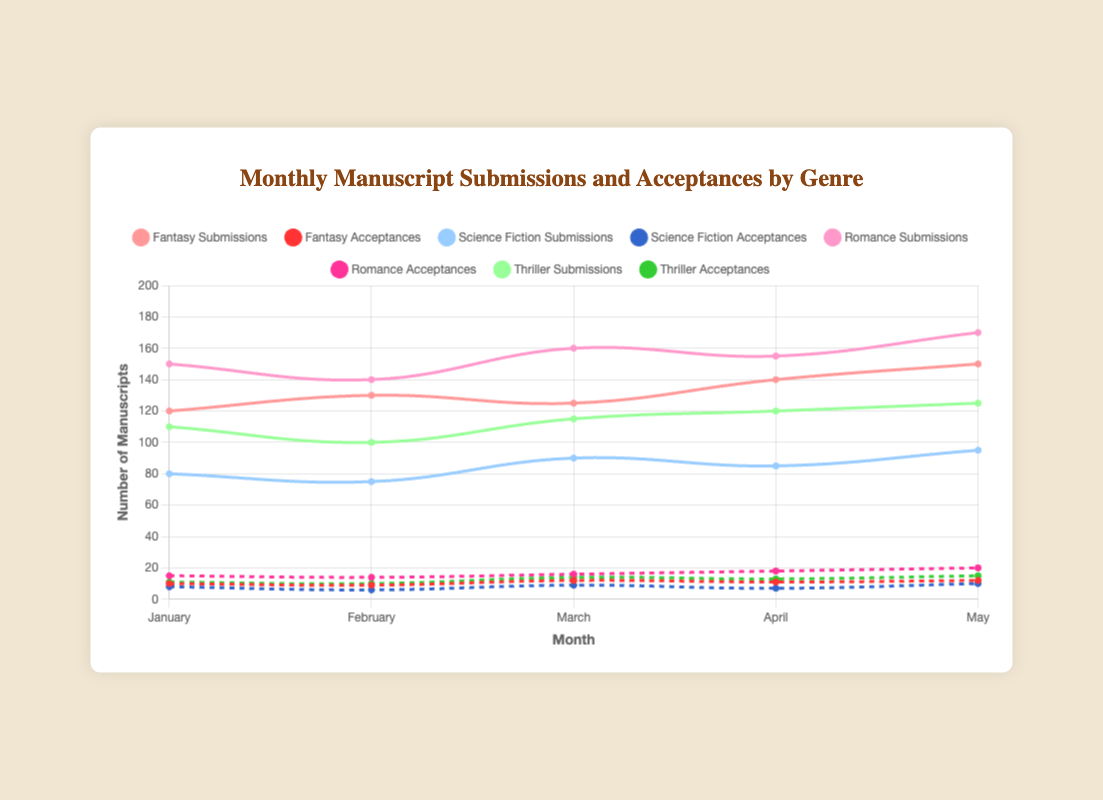What's the total number of Fantasy submissions over the five months? Sum the Fantasy submissions for each month: 120 + 130 + 125 + 140 + 150 = 665
Answer: 665 Which genre had the highest number of submissions in May? Compare the submission numbers in May across all genres: Fantasy (150), Science Fiction (95), Romance (170), Thriller (125). The highest is 170 for Romance.
Answer: Romance What is the difference between the number of Fantasy acceptances and Science Fiction acceptances in March? Find the number of acceptances for Fantasy (12) and Science Fiction (9) in March and calculate the difference: 12 - 9 = 3
Answer: 3 Which genre had the most consistent number of submissions from January to May? Visually compare the submission lines across the months for each genre. Look for the flattest line: Fantasy fluctuates (120 to 150), Science Fiction is relatively consistent (range 75 to 95), Romance has notable increases, Thriller is steady but slightly variable.
Answer: Science Fiction What's the average number of submissions for Romance from January to May? Sum the Romance submissions for each month and divide by 5: (150 + 140 + 160 + 155 + 170) / 5 = 775 / 5 = 155
Answer: 155 Which month saw the highest number of total manuscript submissions across all genres? Add the submissions for each month across all genres and compare: January (120+80+150+110 = 460), February (130+75+140+100 = 445), March (125+90+160+115 = 490), April (140+85+155+120 = 500), May (150+95+170+125 = 540). May has the highest total.
Answer: May How do the number of acceptances for Thrillers in April compare to the number in March? Find the Thriller acceptances in April (13) and in March (14) and compare: 13 is less than 14.
Answer: Less What is the total number of acceptances for all genres in April? Sum the acceptances for each genre in April: 11 (Fantasy) + 7 (Science Fiction) + 18 (Romance) + 13 (Thriller) = 49
Answer: 49 In which month did Science Fiction submissions see the highest increase compared to the previous month? Calculate the monthly increase for Science Fiction submissions: January to February (80-75 = -5), February to March (75-90 = 15), March to April (90-85 = -5), April to May (85-95 = 10). March has the highest increase of +15.
Answer: March Which genre saw both its submissions and acceptances increase from January to February? Compare both submissions and acceptances from January to February for each genre: Fantasy (Submissions up 10, Acceptances down 1), Science Fiction (Submissions down 5, Acceptances down 2), Romance (Submissions down 10, Acceptances down 1), Thriller (Submissions down 10, Acceptances down 1). None show an increase in both.
Answer: None 